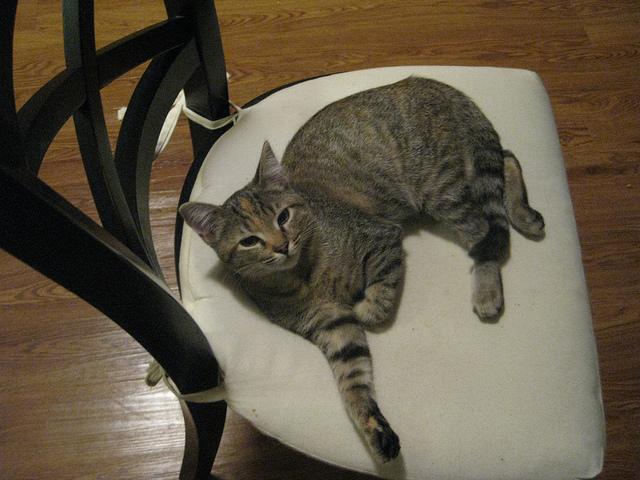What is the cat lying on?
Short answer required. Chair. Is the cat going to jump?
Answer briefly. No. Is this a kitten?
Be succinct. No. Is the cat sleepy?
Quick response, please. Yes. 